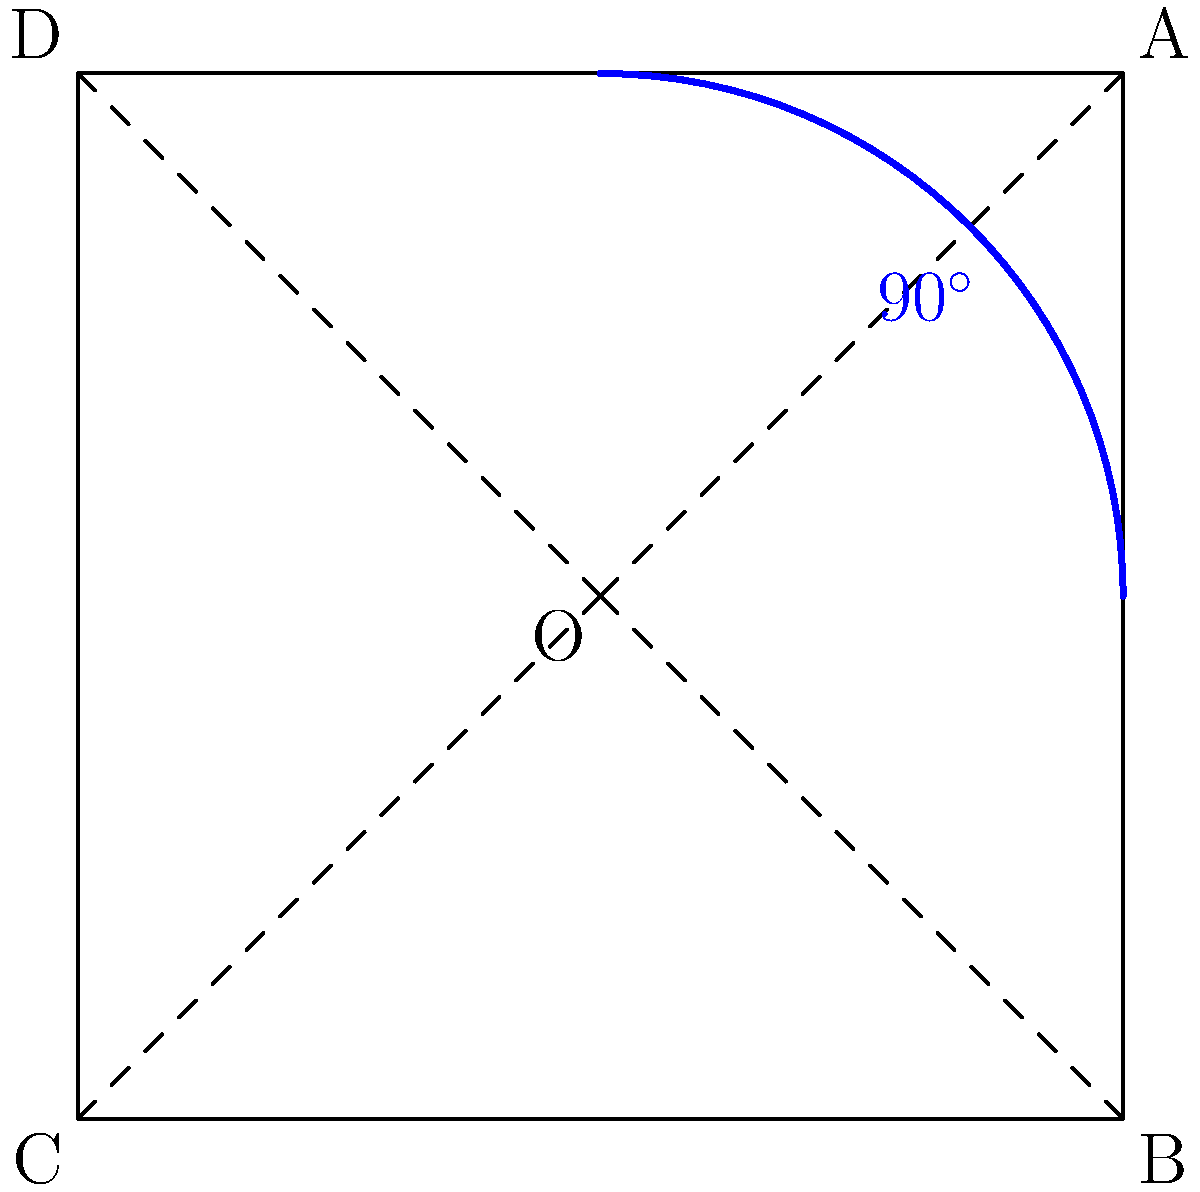In a virtual KISS trivia competition, you're asked about the band's iconic logo. The KISS logo is represented by a square ABCD with center O. If the logo is rotated $90^\circ$ counterclockwise around point O, what will be the new position of point A? Let's approach this step-by-step:

1) The KISS logo is represented by a square ABCD with center O.

2) Point A is initially at coordinates (1,1) relative to O.

3) A $90^\circ$ counterclockwise rotation around a point can be achieved by applying the rotation matrix:
   $$\begin{pmatrix} \cos 90^\circ & -\sin 90^\circ \\ \sin 90^\circ & \cos 90^\circ \end{pmatrix} = \begin{pmatrix} 0 & -1 \\ 1 & 0 \end{pmatrix}$$

4) Applying this rotation to point A(1,1):
   $$\begin{pmatrix} 0 & -1 \\ 1 & 0 \end{pmatrix} \begin{pmatrix} 1 \\ 1 \end{pmatrix} = \begin{pmatrix} -1 \\ 1 \end{pmatrix}$$

5) The new coordinates (-1,1) correspond to point D in the original square.

Therefore, after a $90^\circ$ counterclockwise rotation, point A will move to the position originally occupied by point D.
Answer: D 